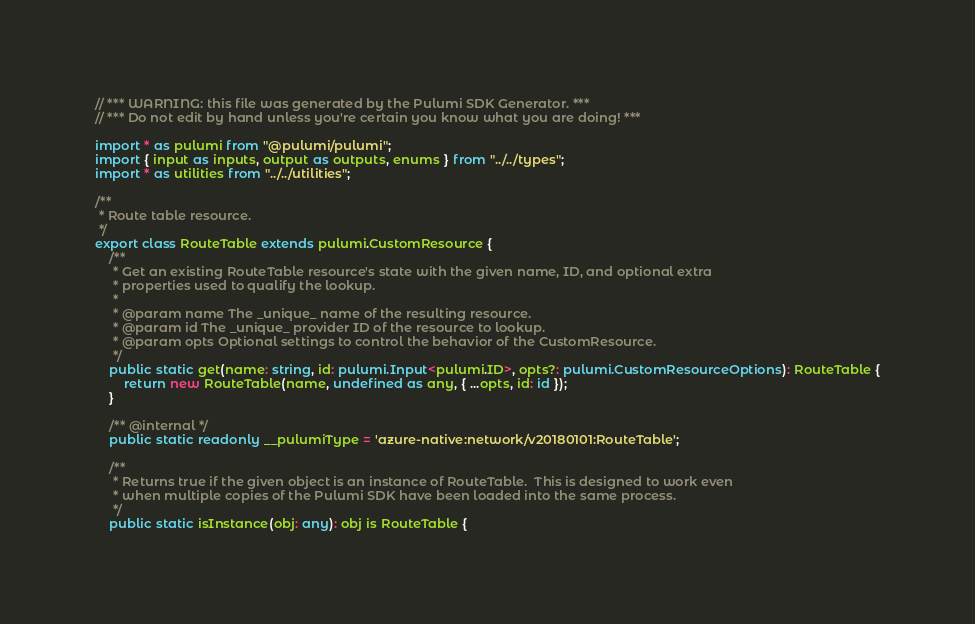<code> <loc_0><loc_0><loc_500><loc_500><_TypeScript_>// *** WARNING: this file was generated by the Pulumi SDK Generator. ***
// *** Do not edit by hand unless you're certain you know what you are doing! ***

import * as pulumi from "@pulumi/pulumi";
import { input as inputs, output as outputs, enums } from "../../types";
import * as utilities from "../../utilities";

/**
 * Route table resource.
 */
export class RouteTable extends pulumi.CustomResource {
    /**
     * Get an existing RouteTable resource's state with the given name, ID, and optional extra
     * properties used to qualify the lookup.
     *
     * @param name The _unique_ name of the resulting resource.
     * @param id The _unique_ provider ID of the resource to lookup.
     * @param opts Optional settings to control the behavior of the CustomResource.
     */
    public static get(name: string, id: pulumi.Input<pulumi.ID>, opts?: pulumi.CustomResourceOptions): RouteTable {
        return new RouteTable(name, undefined as any, { ...opts, id: id });
    }

    /** @internal */
    public static readonly __pulumiType = 'azure-native:network/v20180101:RouteTable';

    /**
     * Returns true if the given object is an instance of RouteTable.  This is designed to work even
     * when multiple copies of the Pulumi SDK have been loaded into the same process.
     */
    public static isInstance(obj: any): obj is RouteTable {</code> 